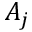<formula> <loc_0><loc_0><loc_500><loc_500>A _ { j }</formula> 